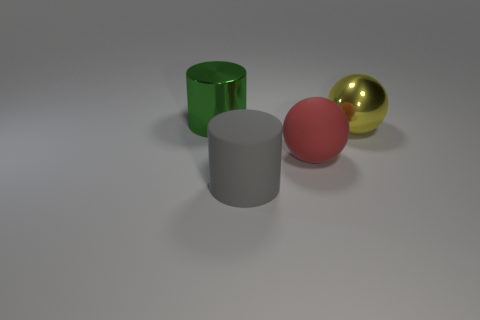Add 2 tiny brown metal cubes. How many objects exist? 6 Add 2 small yellow metallic balls. How many small yellow metallic balls exist? 2 Subtract 0 brown balls. How many objects are left? 4 Subtract all small red matte cubes. Subtract all large matte cylinders. How many objects are left? 3 Add 1 green cylinders. How many green cylinders are left? 2 